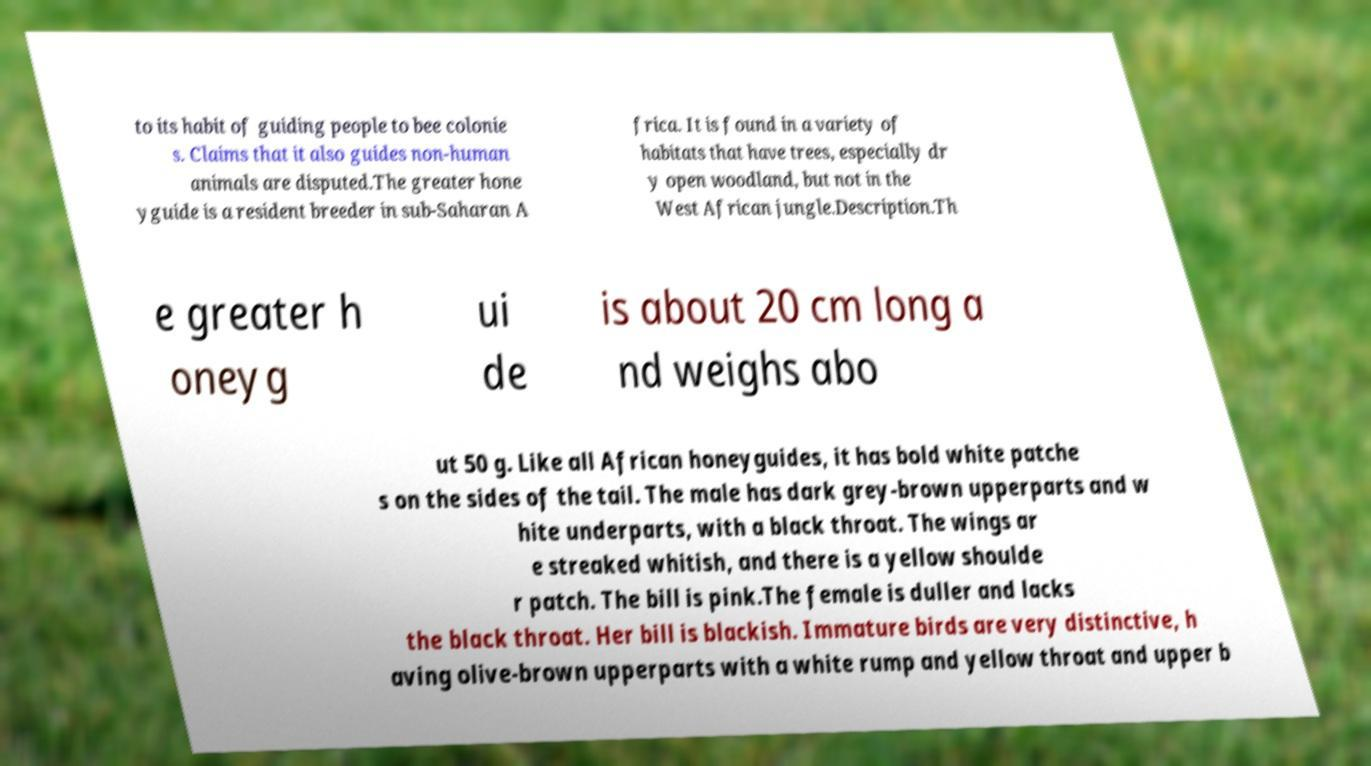For documentation purposes, I need the text within this image transcribed. Could you provide that? to its habit of guiding people to bee colonie s. Claims that it also guides non-human animals are disputed.The greater hone yguide is a resident breeder in sub-Saharan A frica. It is found in a variety of habitats that have trees, especially dr y open woodland, but not in the West African jungle.Description.Th e greater h oneyg ui de is about 20 cm long a nd weighs abo ut 50 g. Like all African honeyguides, it has bold white patche s on the sides of the tail. The male has dark grey-brown upperparts and w hite underparts, with a black throat. The wings ar e streaked whitish, and there is a yellow shoulde r patch. The bill is pink.The female is duller and lacks the black throat. Her bill is blackish. Immature birds are very distinctive, h aving olive-brown upperparts with a white rump and yellow throat and upper b 